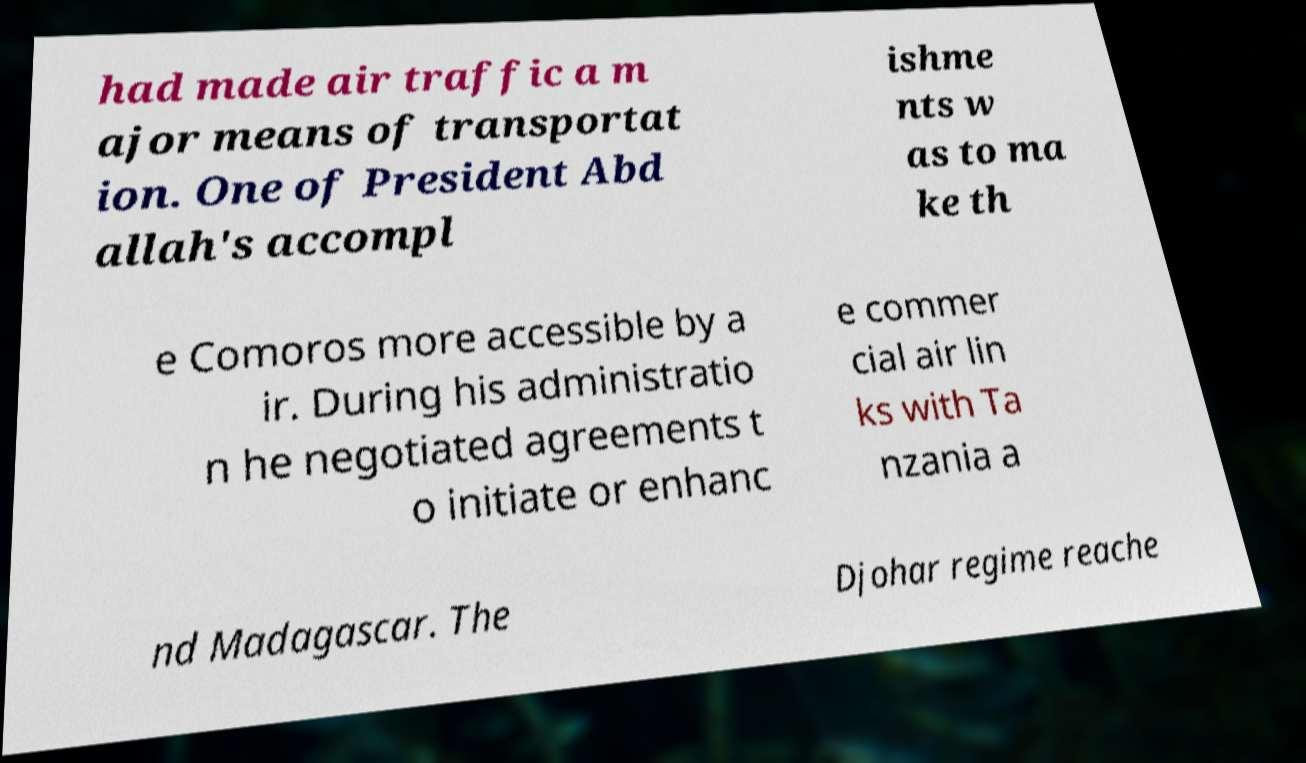Could you extract and type out the text from this image? had made air traffic a m ajor means of transportat ion. One of President Abd allah's accompl ishme nts w as to ma ke th e Comoros more accessible by a ir. During his administratio n he negotiated agreements t o initiate or enhanc e commer cial air lin ks with Ta nzania a nd Madagascar. The Djohar regime reache 